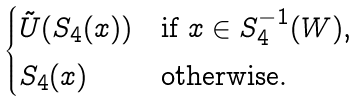<formula> <loc_0><loc_0><loc_500><loc_500>\begin{cases} \tilde { U } ( S _ { 4 } ( x ) ) & \text {if $x \in S_{4}^{-1}(W)$,} \\ S _ { 4 } ( x ) & \text {otherwise.} \end{cases}</formula> 